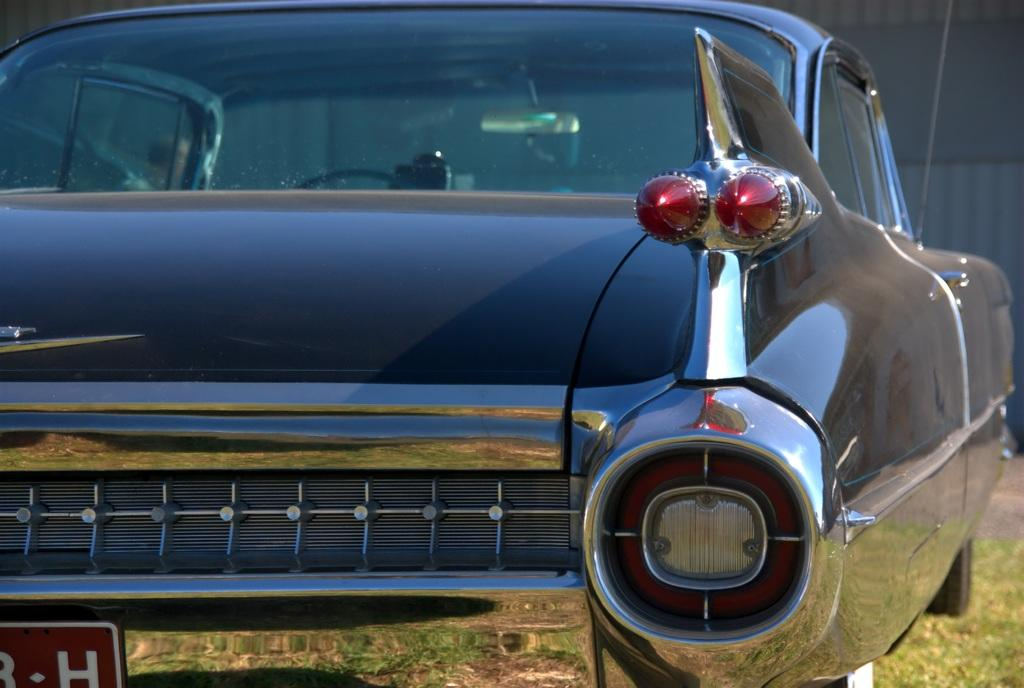What is the main subject of the image? The main subject of the image is a car. Where is the car positioned in the image? The car is in the front of the image. What type of vegetation can be seen in the image? There is grass in the image. Where is the grass located in the image? The grass is located at the right bottom of the image. How many chickens are running along the coast in the image? There are no chickens or coast visible in the image; it features a car in the front and grass at the right bottom. 